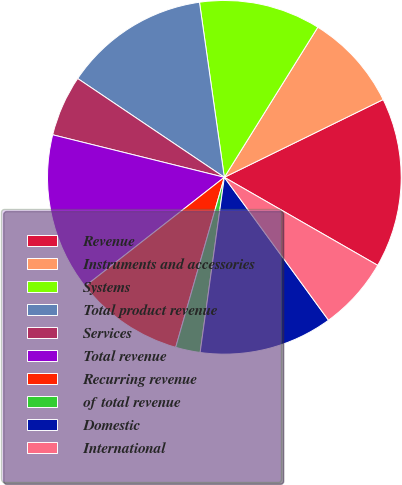<chart> <loc_0><loc_0><loc_500><loc_500><pie_chart><fcel>Revenue<fcel>Instruments and accessories<fcel>Systems<fcel>Total product revenue<fcel>Services<fcel>Total revenue<fcel>Recurring revenue<fcel>of total revenue<fcel>Domestic<fcel>International<nl><fcel>15.54%<fcel>8.89%<fcel>11.11%<fcel>13.32%<fcel>5.57%<fcel>14.43%<fcel>10.0%<fcel>2.25%<fcel>12.21%<fcel>6.68%<nl></chart> 